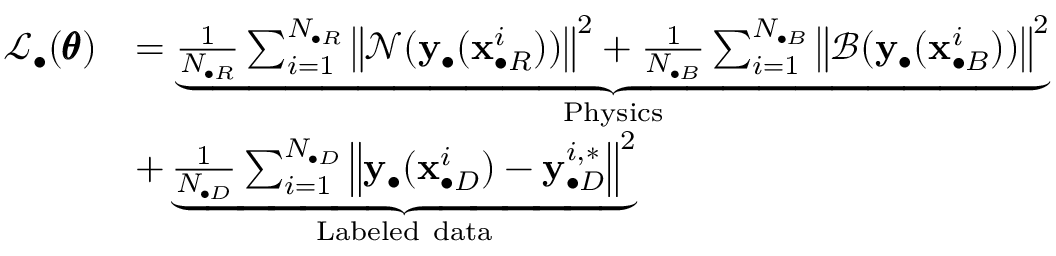<formula> <loc_0><loc_0><loc_500><loc_500>\begin{array} { r l } { \mathcal { L } _ { \bullet } ( \pm b { \theta } ) } & { = \underbrace { \frac { 1 } { N _ { \bullet R } } \sum _ { i = 1 } ^ { N _ { \bullet R } } { \left \| \mathcal { N } ( y _ { \bullet } ( x _ { \bullet R } ^ { i } ) ) \right \| ^ { 2 } } + \frac { 1 } { N _ { \bullet B } } \sum _ { i = 1 } ^ { N _ { \bullet B } } { \left \| \mathcal { B } ( y _ { \bullet } ( x _ { \bullet B } ^ { i } ) ) \right \| ^ { 2 } } } _ { P h y s i c s } } \\ & { + \underbrace { \frac { 1 } { N _ { \bullet D } } \sum _ { i = 1 } ^ { N _ { \bullet D } } { \left \| y _ { \bullet } ( x _ { \bullet D } ^ { i } ) - y _ { \bullet D } ^ { i , * } \right \| ^ { 2 } } } _ { L a b e l e d d a t a } } \end{array}</formula> 